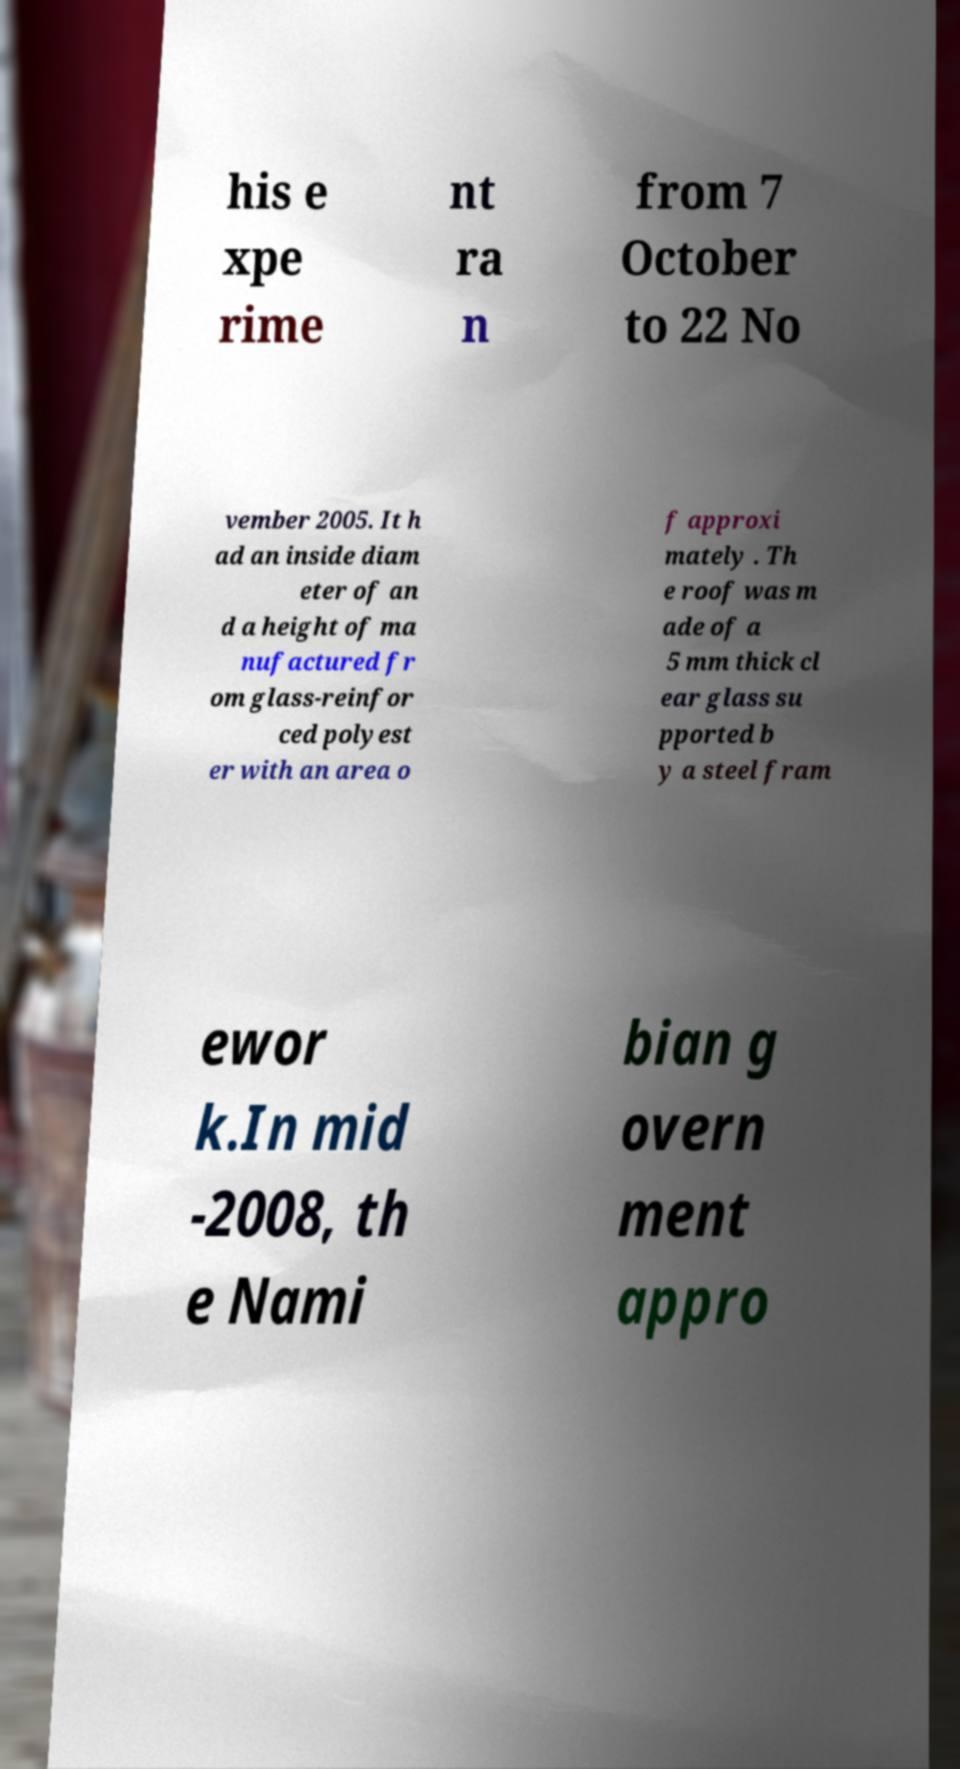Could you extract and type out the text from this image? his e xpe rime nt ra n from 7 October to 22 No vember 2005. It h ad an inside diam eter of an d a height of ma nufactured fr om glass-reinfor ced polyest er with an area o f approxi mately . Th e roof was m ade of a 5 mm thick cl ear glass su pported b y a steel fram ewor k.In mid -2008, th e Nami bian g overn ment appro 